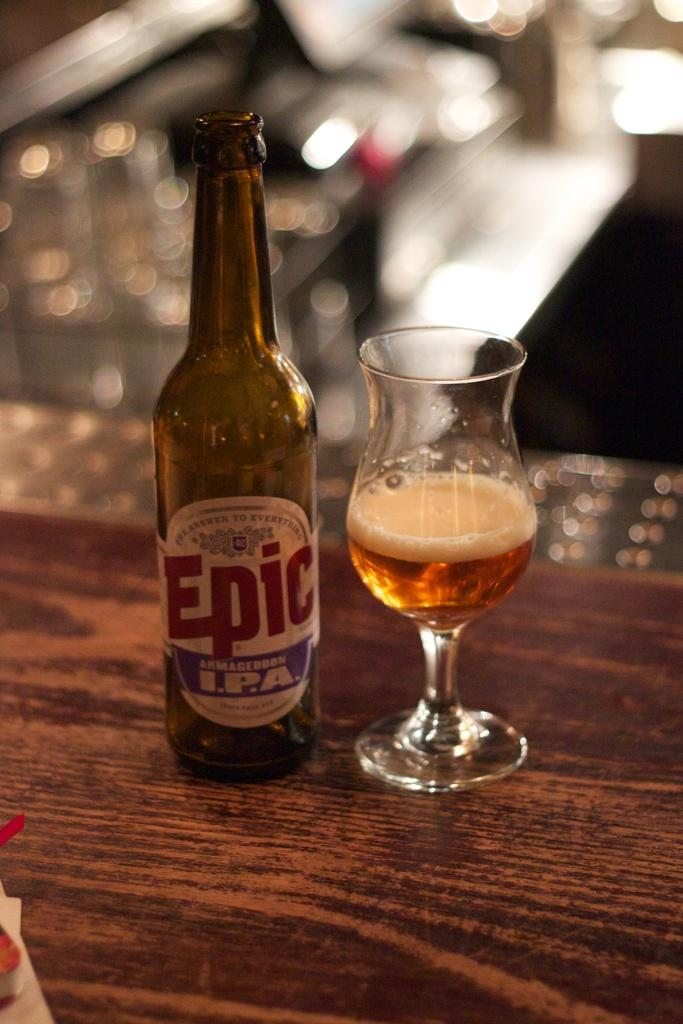<image>
Give a short and clear explanation of the subsequent image. A bottle of Epic I.P.A. is on a wooden surface next to a glass. 